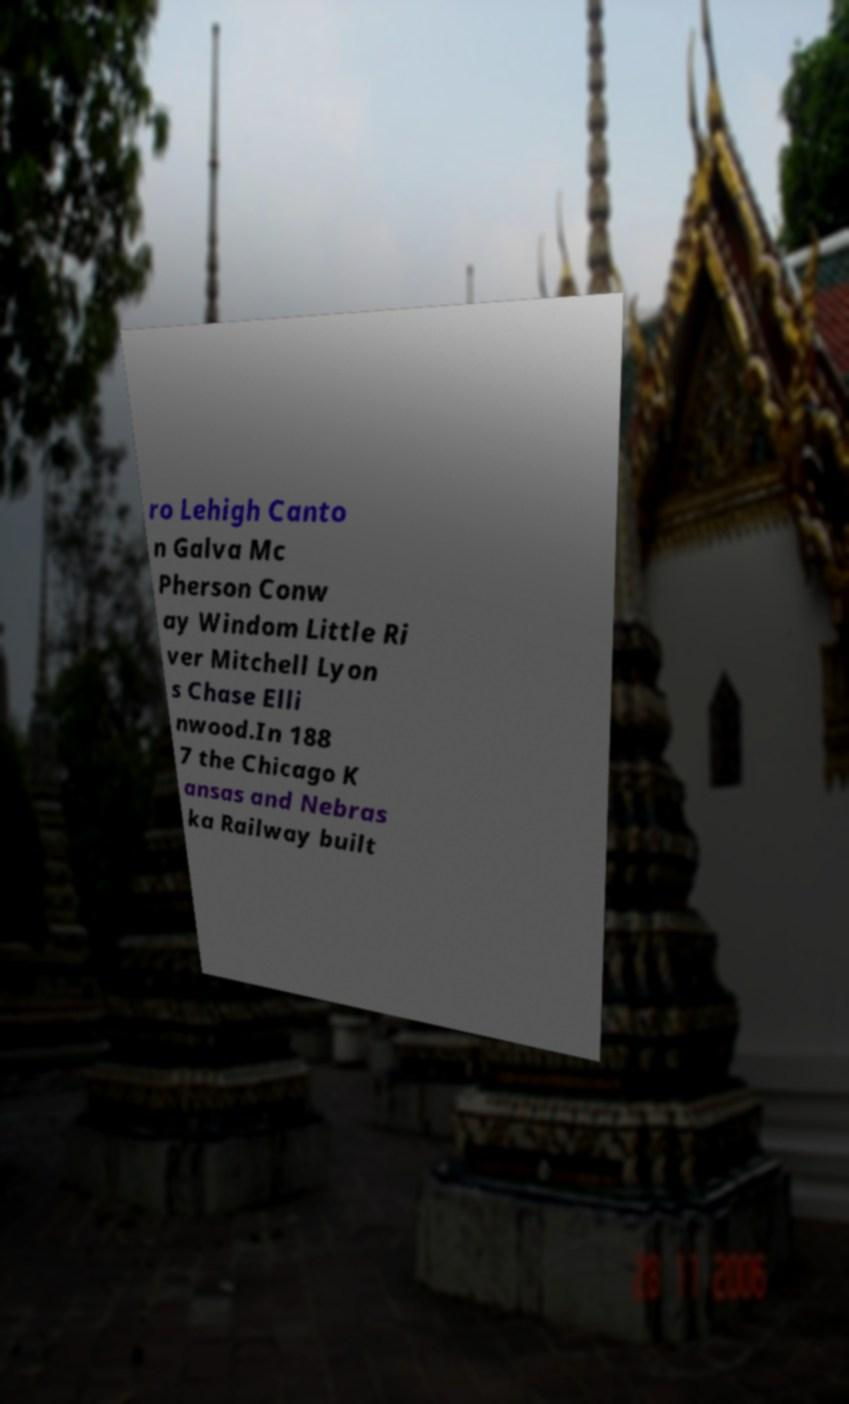I need the written content from this picture converted into text. Can you do that? ro Lehigh Canto n Galva Mc Pherson Conw ay Windom Little Ri ver Mitchell Lyon s Chase Elli nwood.In 188 7 the Chicago K ansas and Nebras ka Railway built 